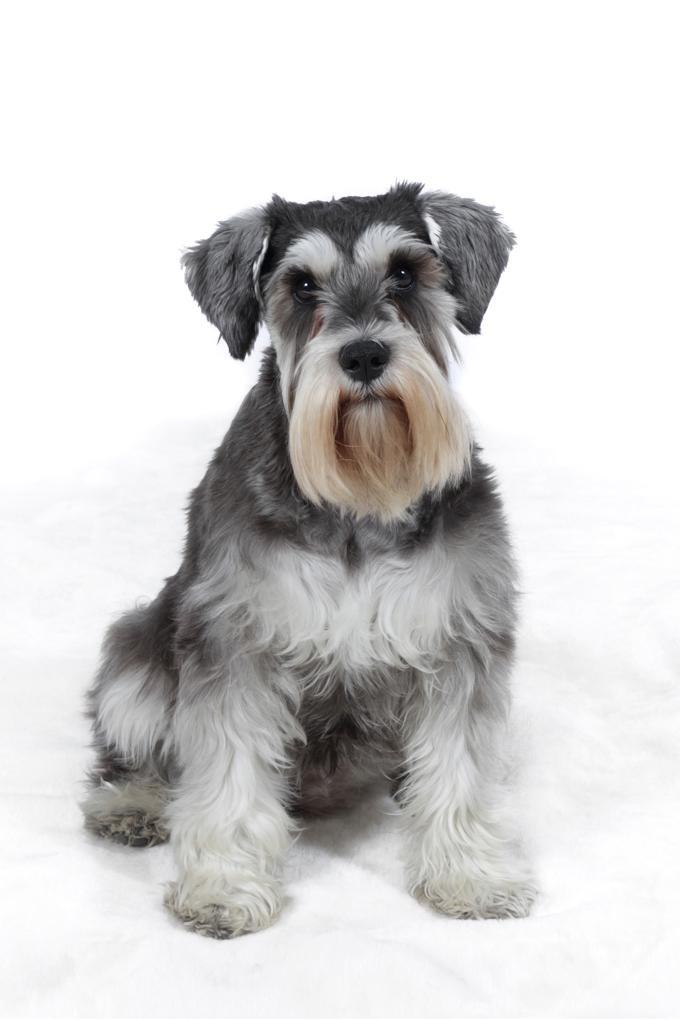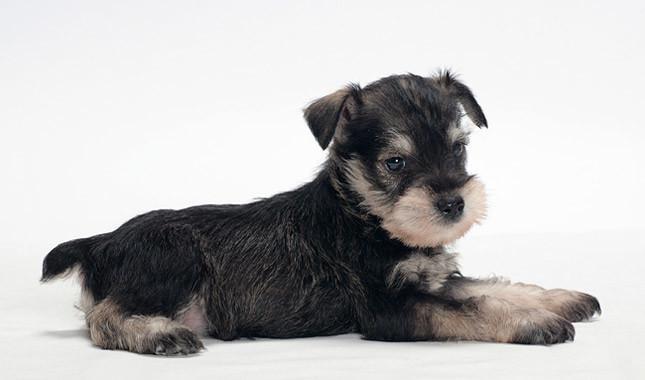The first image is the image on the left, the second image is the image on the right. Examine the images to the left and right. Is the description "One dog's body is facing to the left." accurate? Answer yes or no. No. The first image is the image on the left, the second image is the image on the right. Assess this claim about the two images: "An image shows exactly one schnauzer, which stands on all fours facing leftward.". Correct or not? Answer yes or no. No. The first image is the image on the left, the second image is the image on the right. Evaluate the accuracy of this statement regarding the images: "An image contains a schnauzer standing and turned leftward.". Is it true? Answer yes or no. No. 